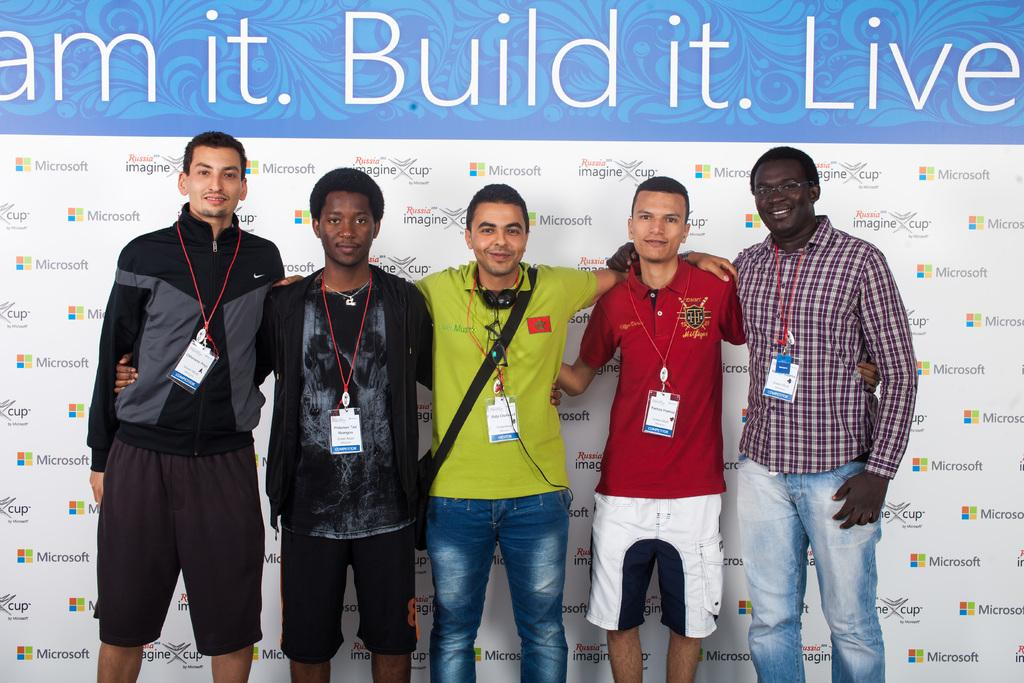What can be observed about the people in the image? There are people standing in the image. What are the people wearing that might provide identification? The people are wearing ID cards. What is visible in the background of the image? There is a banner with text and logos in the background of the image. How many tomatoes are being used to write on the sticks in the image? There are no tomatoes or sticks present in the image. What color is the chalk used to draw on the banner in the image? There is no chalk visible in the image; the banner has text and logos printed on it. 